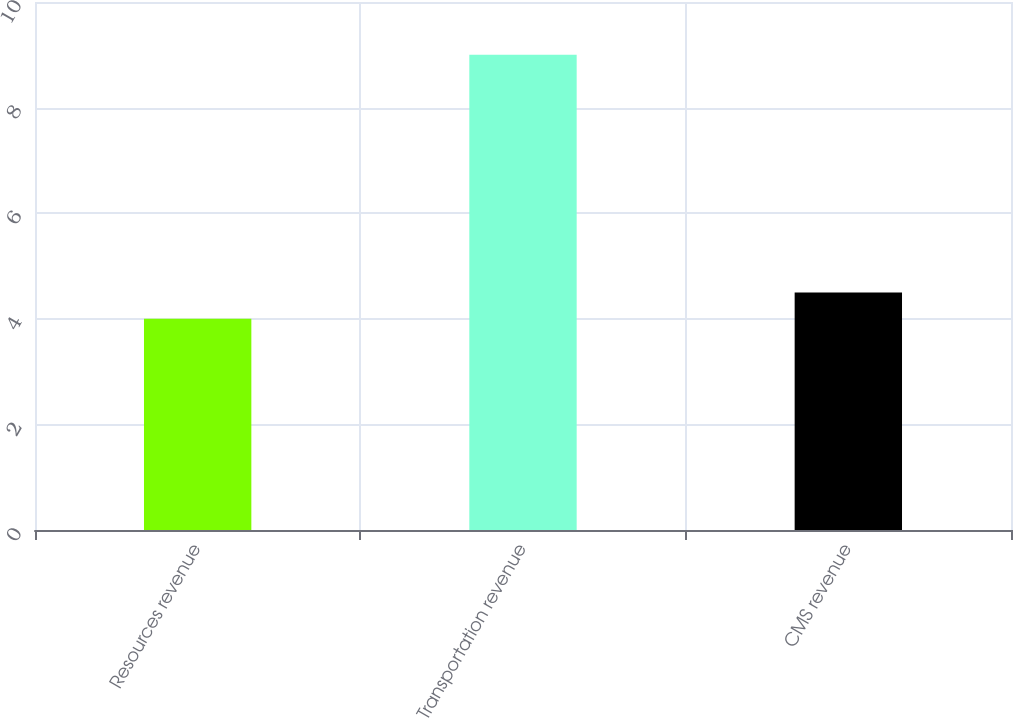<chart> <loc_0><loc_0><loc_500><loc_500><bar_chart><fcel>Resources revenue<fcel>Transportation revenue<fcel>CMS revenue<nl><fcel>4<fcel>9<fcel>4.5<nl></chart> 